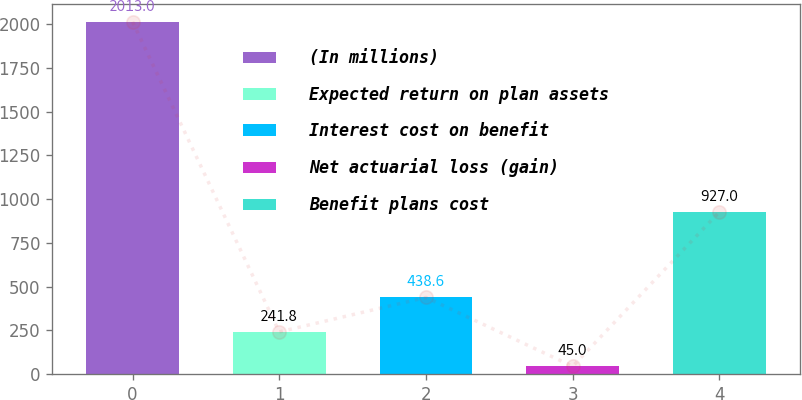<chart> <loc_0><loc_0><loc_500><loc_500><bar_chart><fcel>(In millions)<fcel>Expected return on plan assets<fcel>Interest cost on benefit<fcel>Net actuarial loss (gain)<fcel>Benefit plans cost<nl><fcel>2013<fcel>241.8<fcel>438.6<fcel>45<fcel>927<nl></chart> 